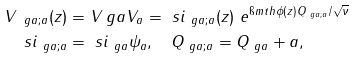Convert formula to latex. <formula><loc_0><loc_0><loc_500><loc_500>V _ { \ g a ; a } ( z ) & = V _ { \ } g a V _ { a } = \ s i _ { \ g a ; a } ( z ) \ e ^ { \i m t h \phi ( z ) Q _ { \ g a ; a } / \sqrt { \nu } } \\ \ s i _ { \ g a ; a } & = \ s i _ { \ g a } \psi _ { a } , \quad Q _ { \ g a ; a } = Q _ { \ g a } + a ,</formula> 